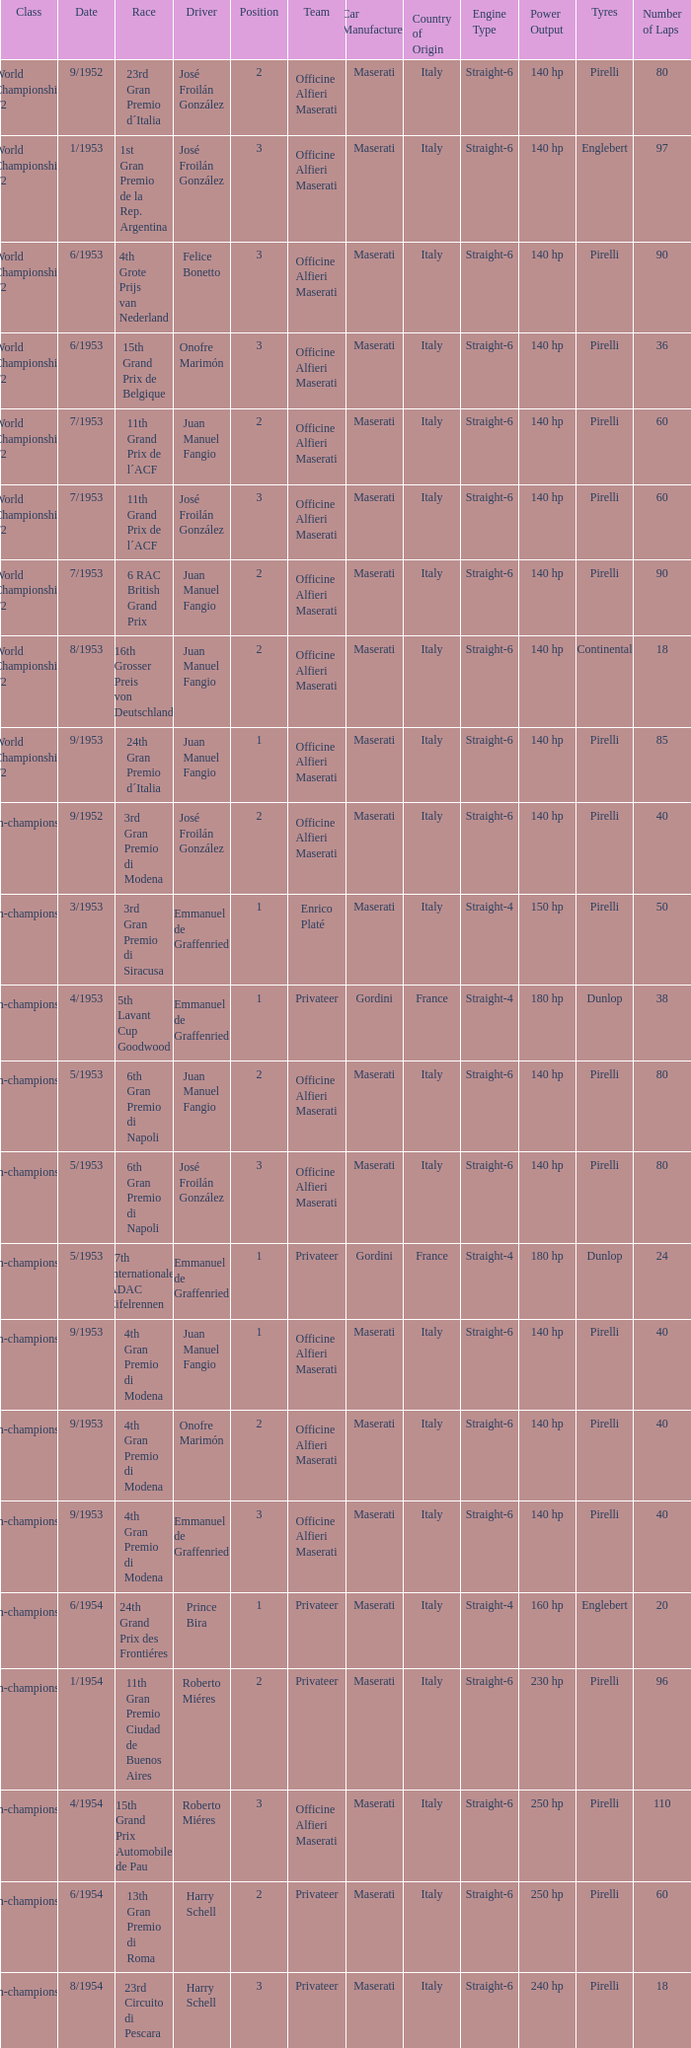What class has the date of 8/1954? Non-championship F1. 